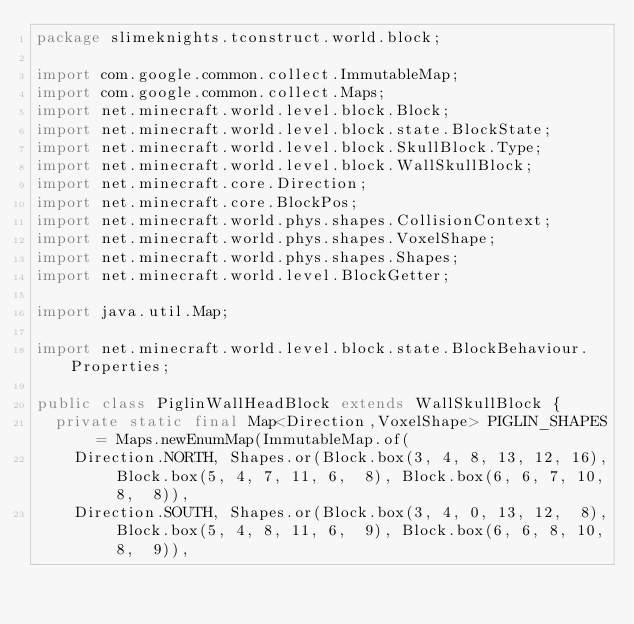Convert code to text. <code><loc_0><loc_0><loc_500><loc_500><_Java_>package slimeknights.tconstruct.world.block;

import com.google.common.collect.ImmutableMap;
import com.google.common.collect.Maps;
import net.minecraft.world.level.block.Block;
import net.minecraft.world.level.block.state.BlockState;
import net.minecraft.world.level.block.SkullBlock.Type;
import net.minecraft.world.level.block.WallSkullBlock;
import net.minecraft.core.Direction;
import net.minecraft.core.BlockPos;
import net.minecraft.world.phys.shapes.CollisionContext;
import net.minecraft.world.phys.shapes.VoxelShape;
import net.minecraft.world.phys.shapes.Shapes;
import net.minecraft.world.level.BlockGetter;

import java.util.Map;

import net.minecraft.world.level.block.state.BlockBehaviour.Properties;

public class PiglinWallHeadBlock extends WallSkullBlock {
  private static final Map<Direction,VoxelShape> PIGLIN_SHAPES = Maps.newEnumMap(ImmutableMap.of(
    Direction.NORTH, Shapes.or(Block.box(3, 4, 8, 13, 12, 16), Block.box(5, 4, 7, 11, 6,  8), Block.box(6, 6, 7, 10, 8,  8)),
    Direction.SOUTH, Shapes.or(Block.box(3, 4, 0, 13, 12,  8), Block.box(5, 4, 8, 11, 6,  9), Block.box(6, 6, 8, 10, 8,  9)),</code> 